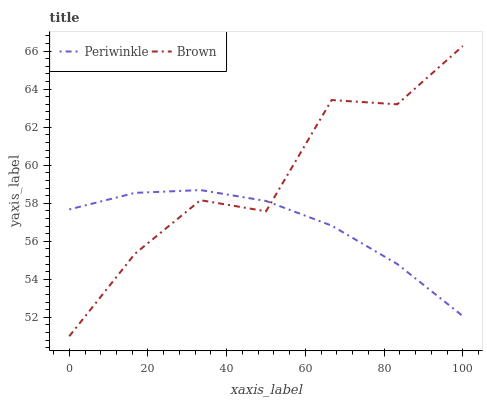Does Periwinkle have the minimum area under the curve?
Answer yes or no. Yes. Does Brown have the maximum area under the curve?
Answer yes or no. Yes. Does Periwinkle have the maximum area under the curve?
Answer yes or no. No. Is Periwinkle the smoothest?
Answer yes or no. Yes. Is Brown the roughest?
Answer yes or no. Yes. Is Periwinkle the roughest?
Answer yes or no. No. Does Brown have the lowest value?
Answer yes or no. Yes. Does Periwinkle have the lowest value?
Answer yes or no. No. Does Brown have the highest value?
Answer yes or no. Yes. Does Periwinkle have the highest value?
Answer yes or no. No. Does Periwinkle intersect Brown?
Answer yes or no. Yes. Is Periwinkle less than Brown?
Answer yes or no. No. Is Periwinkle greater than Brown?
Answer yes or no. No. 